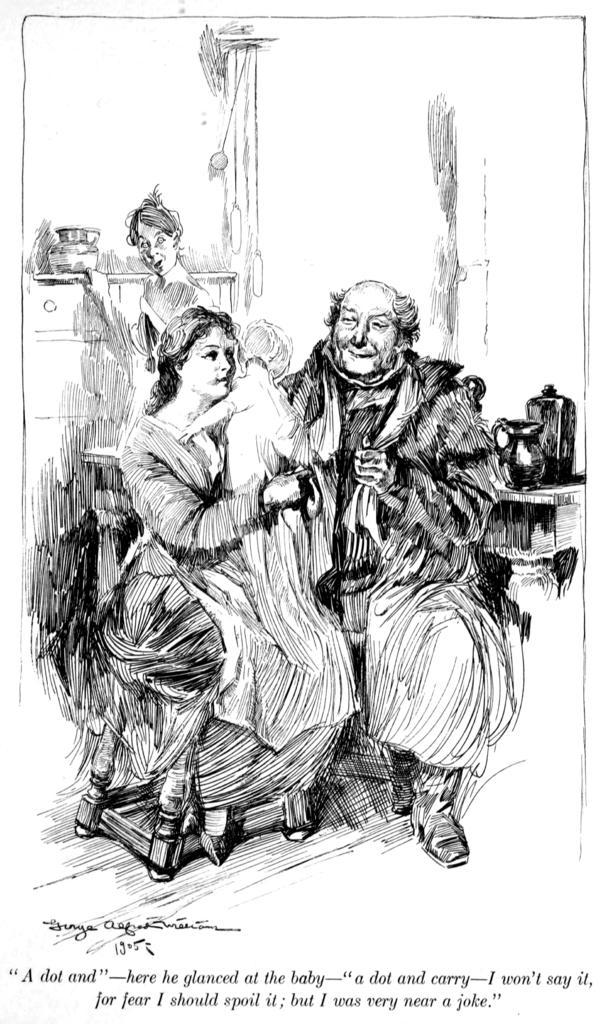Can you describe this image briefly? In this image we can see there is an art of two persons sitting on the chair, one of them is holding a baby in her hand, behind them there is a person standing, behind the person there is a cupboard and there is an object on it. At the bottom of the image there is some text. 